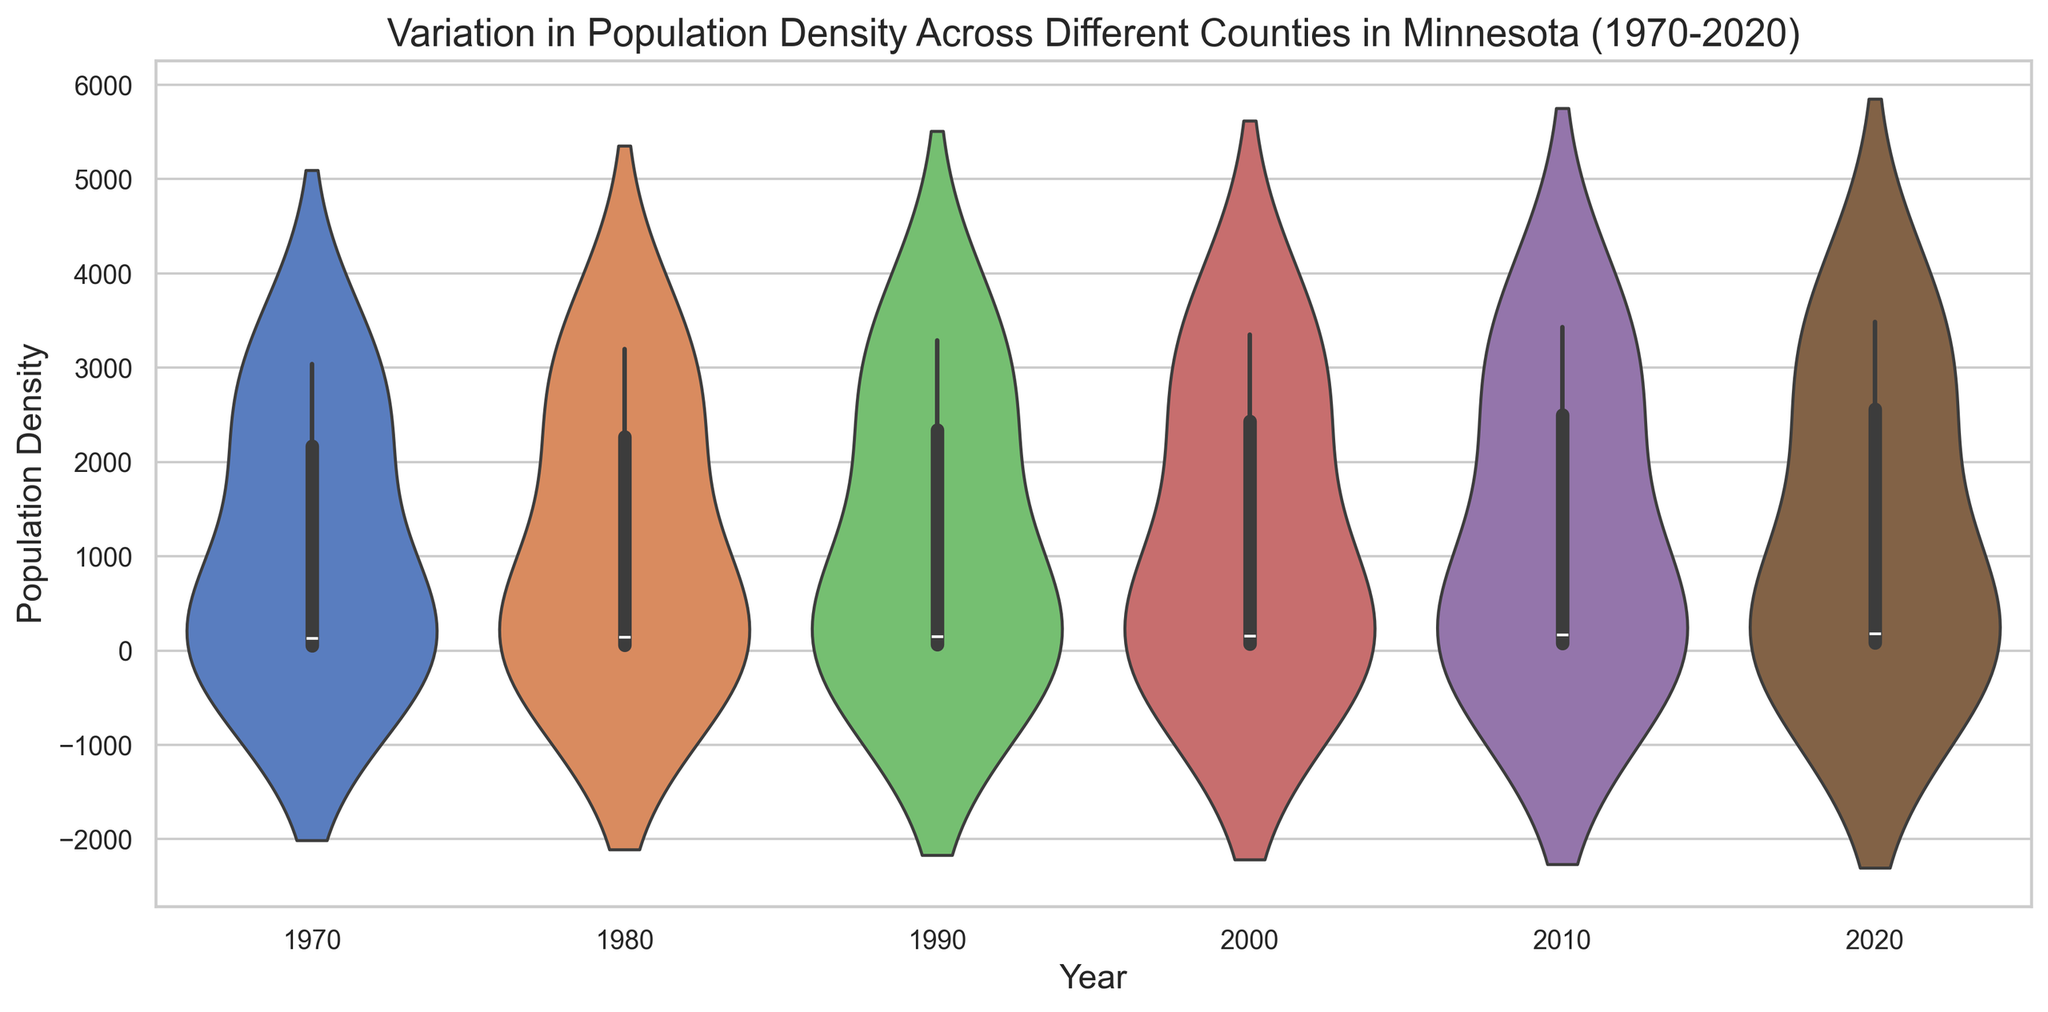What does the overall spread of the population density look like for the year 1970? The spread of population density for 1970 is represented by the width of the violin plot at different population density levels. The width indicates where most of the population densities are concentrated and how varied they are. In 1970, the plot shows a wide spread at lower densities with a concentration at higher densities, suggesting varied population densities across counties.
Answer: Wide spread with concentration at higher densities How does the range of population density change from 1970 to 2020? By visually comparing the height and shape of the violin plots from 1970 to 2020, one can see that the range of population density has increased slightly. The plot for 2020 is slightly higher, indicating a wider range of population densities across counties.
Answer: Range has slightly increased Which year shows the highest population density range among the counties? The year with the widest spread in the violin plot indicates the highest range of population densities. By comparing the height of all the plots, it can be observed that 2020 shows the highest population density range.
Answer: 2020 How has the median population density changed over the years? The median population density is indicated by the white dot within the violin plots. Observing the central position of these dots, it is clear that the median density has steadily increased over the years.
Answer: Increased Among the given years, do any exhibit similar population density ranges? By comparing the width and height of the violin plots, it can be observed that some years, like 1970 and 1980, show similar population density ranges. Both have relatively wide and short plots compared to other years.
Answer: 1970 and 1980 Can we determine which county might have driven the increase in population density from 1970 to 2020? By analyzing the increasing trend of population density in the violin plots, and knowing the counties with inherently high population densities (e.g., Hennepin and Ramsey), it is likely these counties contributed significantly to the increase.
Answer: Hennepin and Ramsey Which year exhibits the most concentrated population density distribution? A more concentrated distribution will be shown by a violin plot with less width variation. Observing the plots, the year 1980 shows the most concentrated population density distribution with less spread compared to other years.
Answer: 1980 Has there been any year with a significant outlier in population density? A significant outlier would appear as a distinct section of the violin plot. By examining all the plots, there do not appear to be any years with a pronounced outlier in population density for the given data.
Answer: No significant outlier 